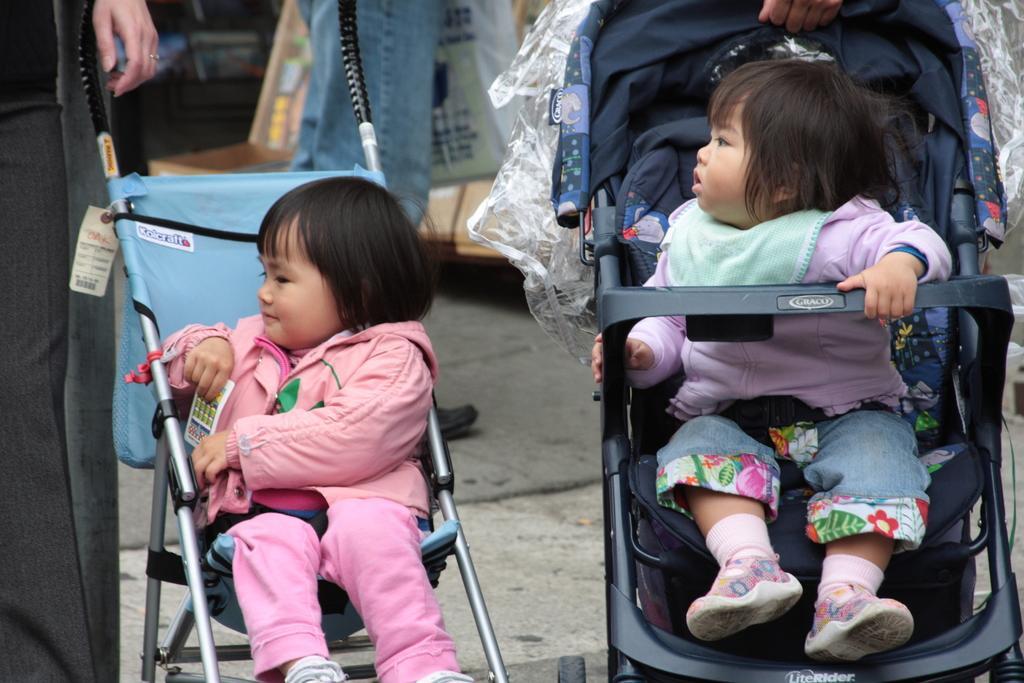In one or two sentences, can you explain what this image depicts? This image consists of two kids sitting in the trolleys. In the background, we can see few persons walking. At the bottom, there is a road. And we can see a tag tied to the trolley. 